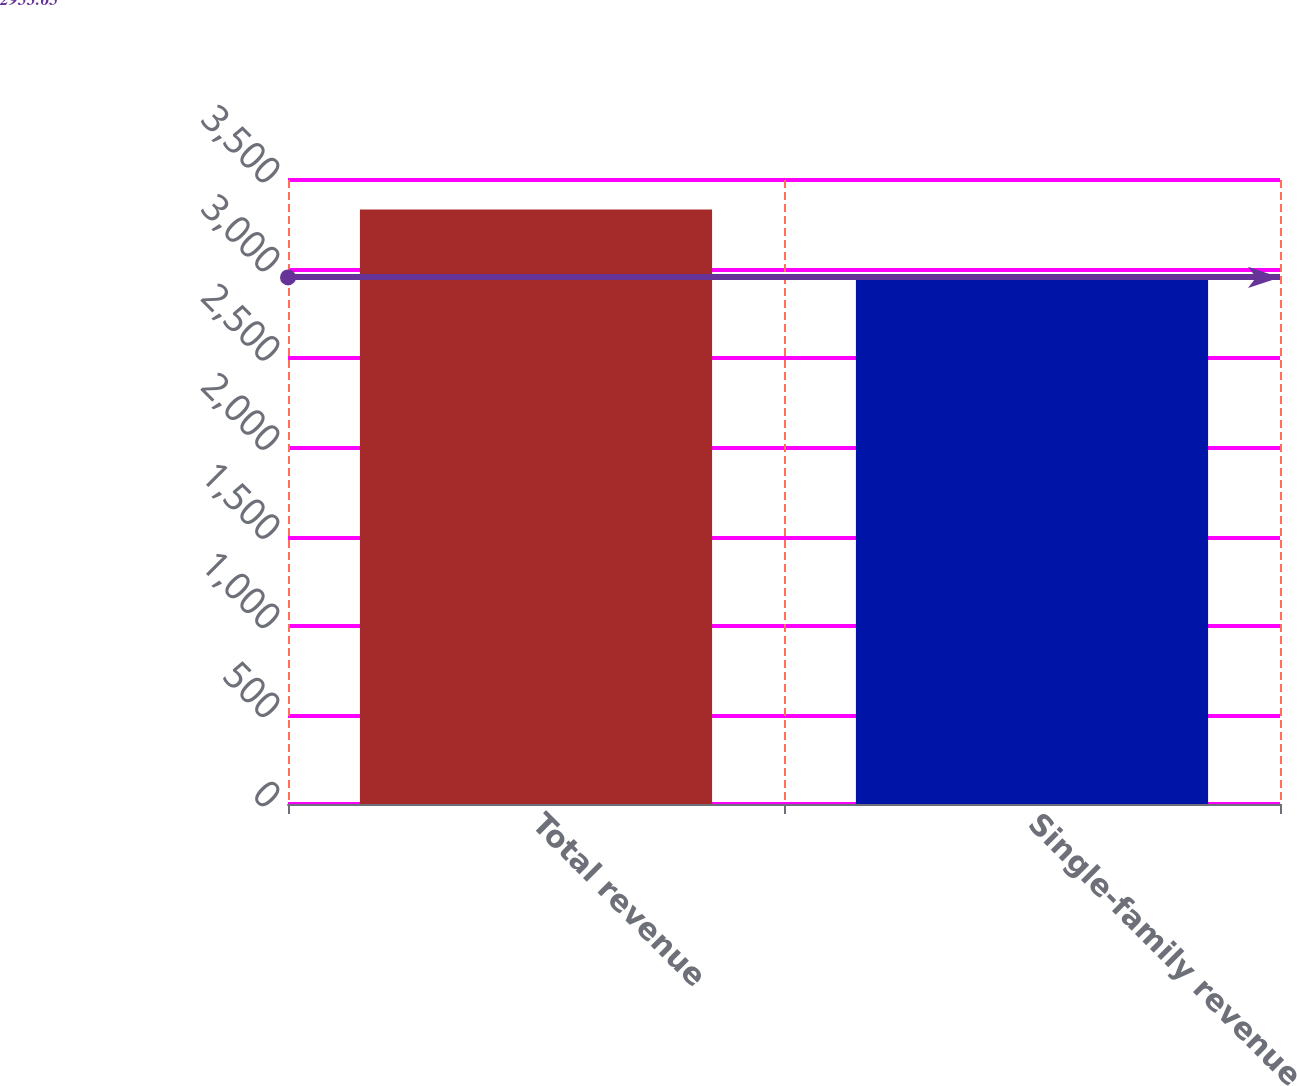Convert chart to OTSL. <chart><loc_0><loc_0><loc_500><loc_500><bar_chart><fcel>Total revenue<fcel>Single-family revenue<nl><fcel>3335<fcel>2951<nl></chart> 